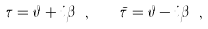<formula> <loc_0><loc_0><loc_500><loc_500>\tau = \vartheta + i \beta \ , \quad \bar { \tau } = \vartheta - i \beta \ ,</formula> 